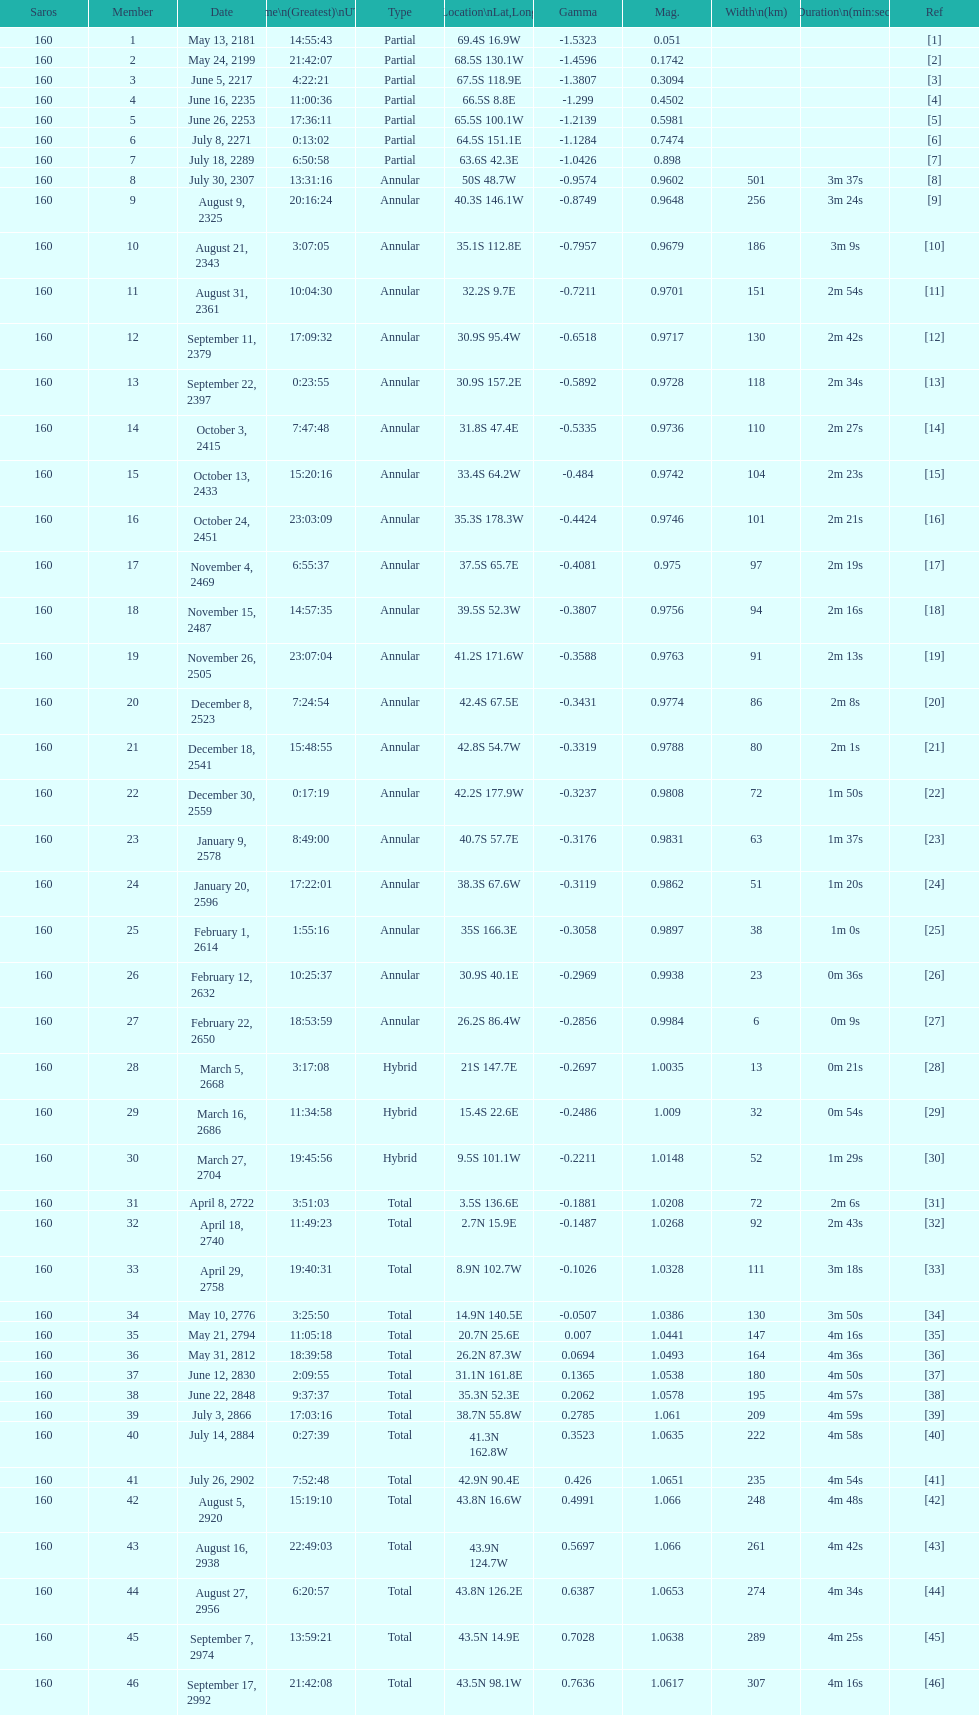How long did the the saros on july 30, 2307 last for? 3m 37s. 